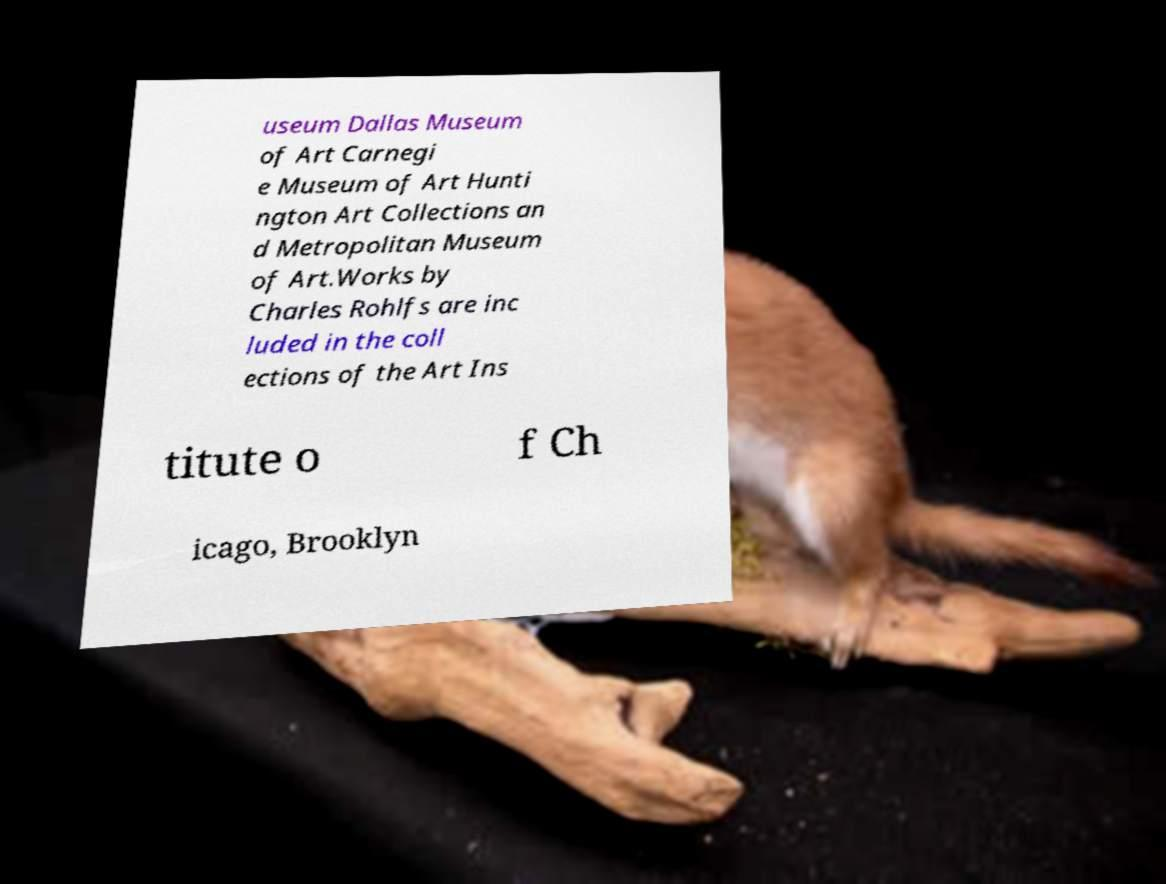Could you extract and type out the text from this image? useum Dallas Museum of Art Carnegi e Museum of Art Hunti ngton Art Collections an d Metropolitan Museum of Art.Works by Charles Rohlfs are inc luded in the coll ections of the Art Ins titute o f Ch icago, Brooklyn 